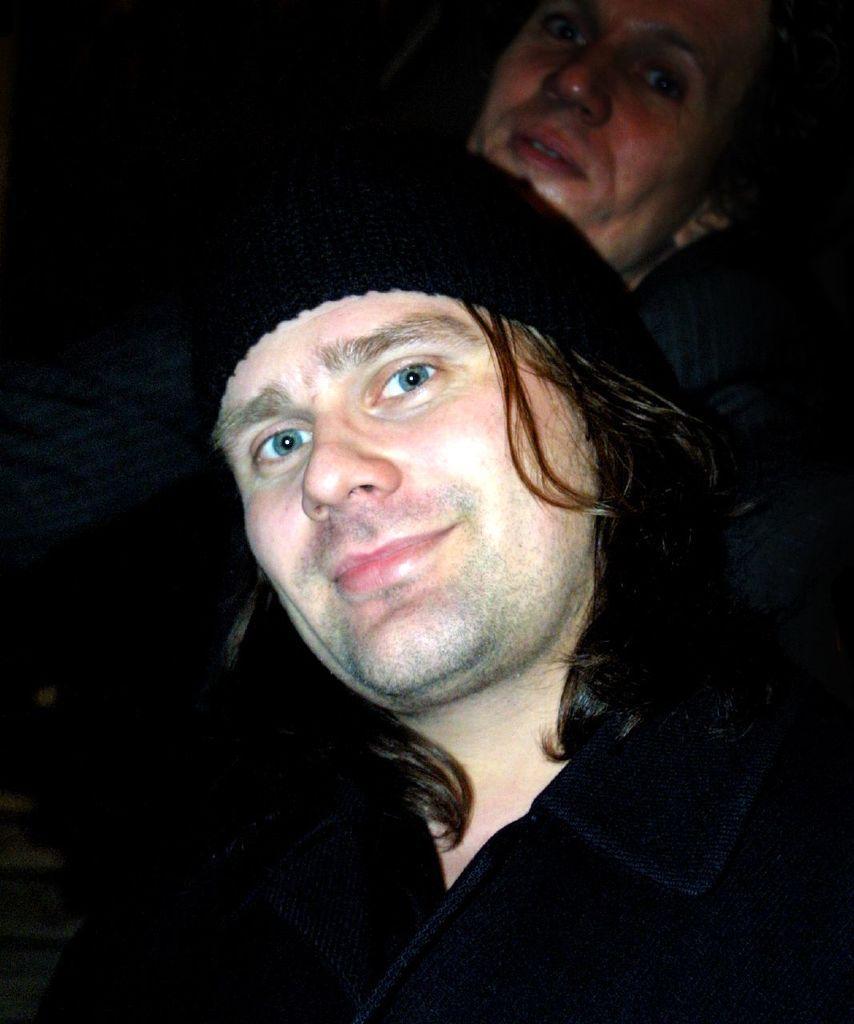Could you give a brief overview of what you see in this image? In this image we can see two persons wearing black color dress, cap posing for a photograph. 